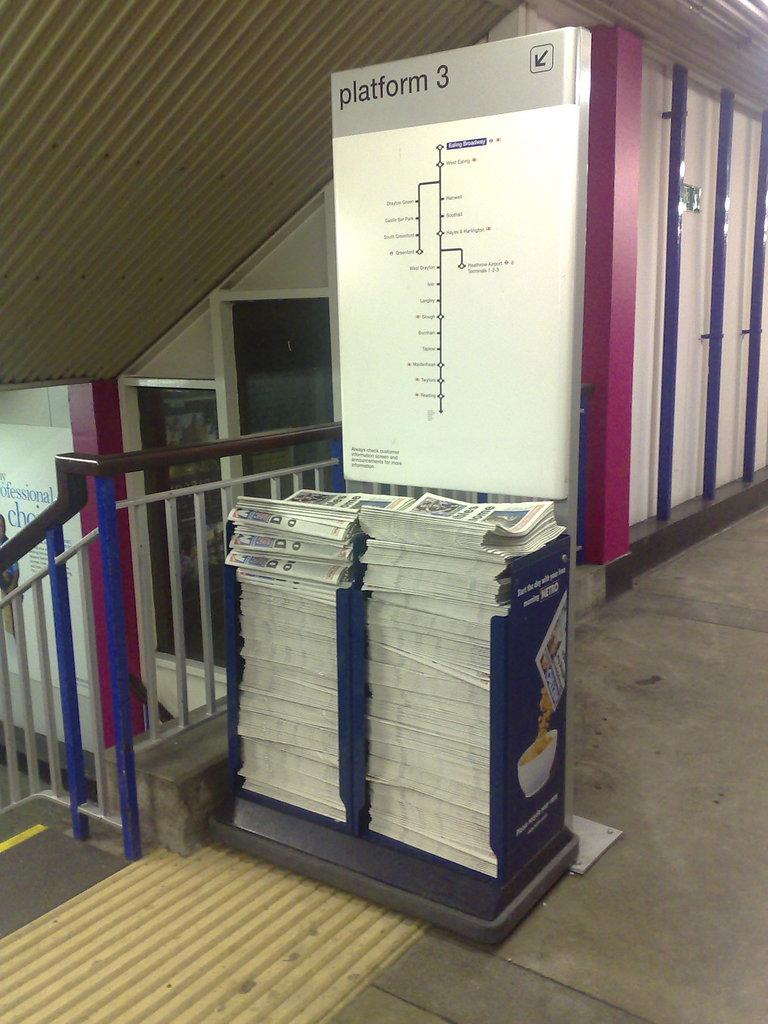What type of reading material is present in the image? There are newspapers in the image. How are the newspapers organized or displayed? The newspapers are kept in a paper stand. What architectural feature can be seen on the left side of the wind, fog, or tooth present in the image? There is no wind, fog, or tooth present in the image. What type of tooth is visible in the image? There is no tooth present in the image. 